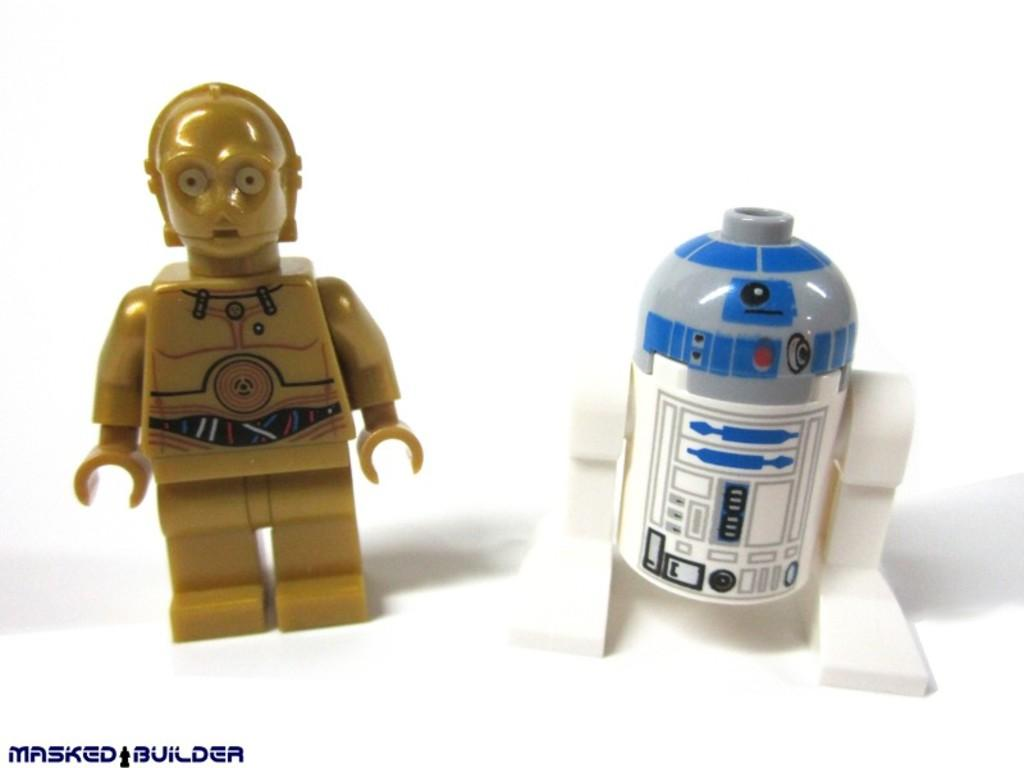What type of object can be seen in the image? There is a toy in the image. What other object is visible in the image? There is a bottle in the image. Is there any text or marking in the image? Yes, there is a watermark in the bottom left corner of the image. How many chickens are visible in the image? There are no chickens present in the image. Is there a ghost visible in the image? There is no ghost present in the image. 